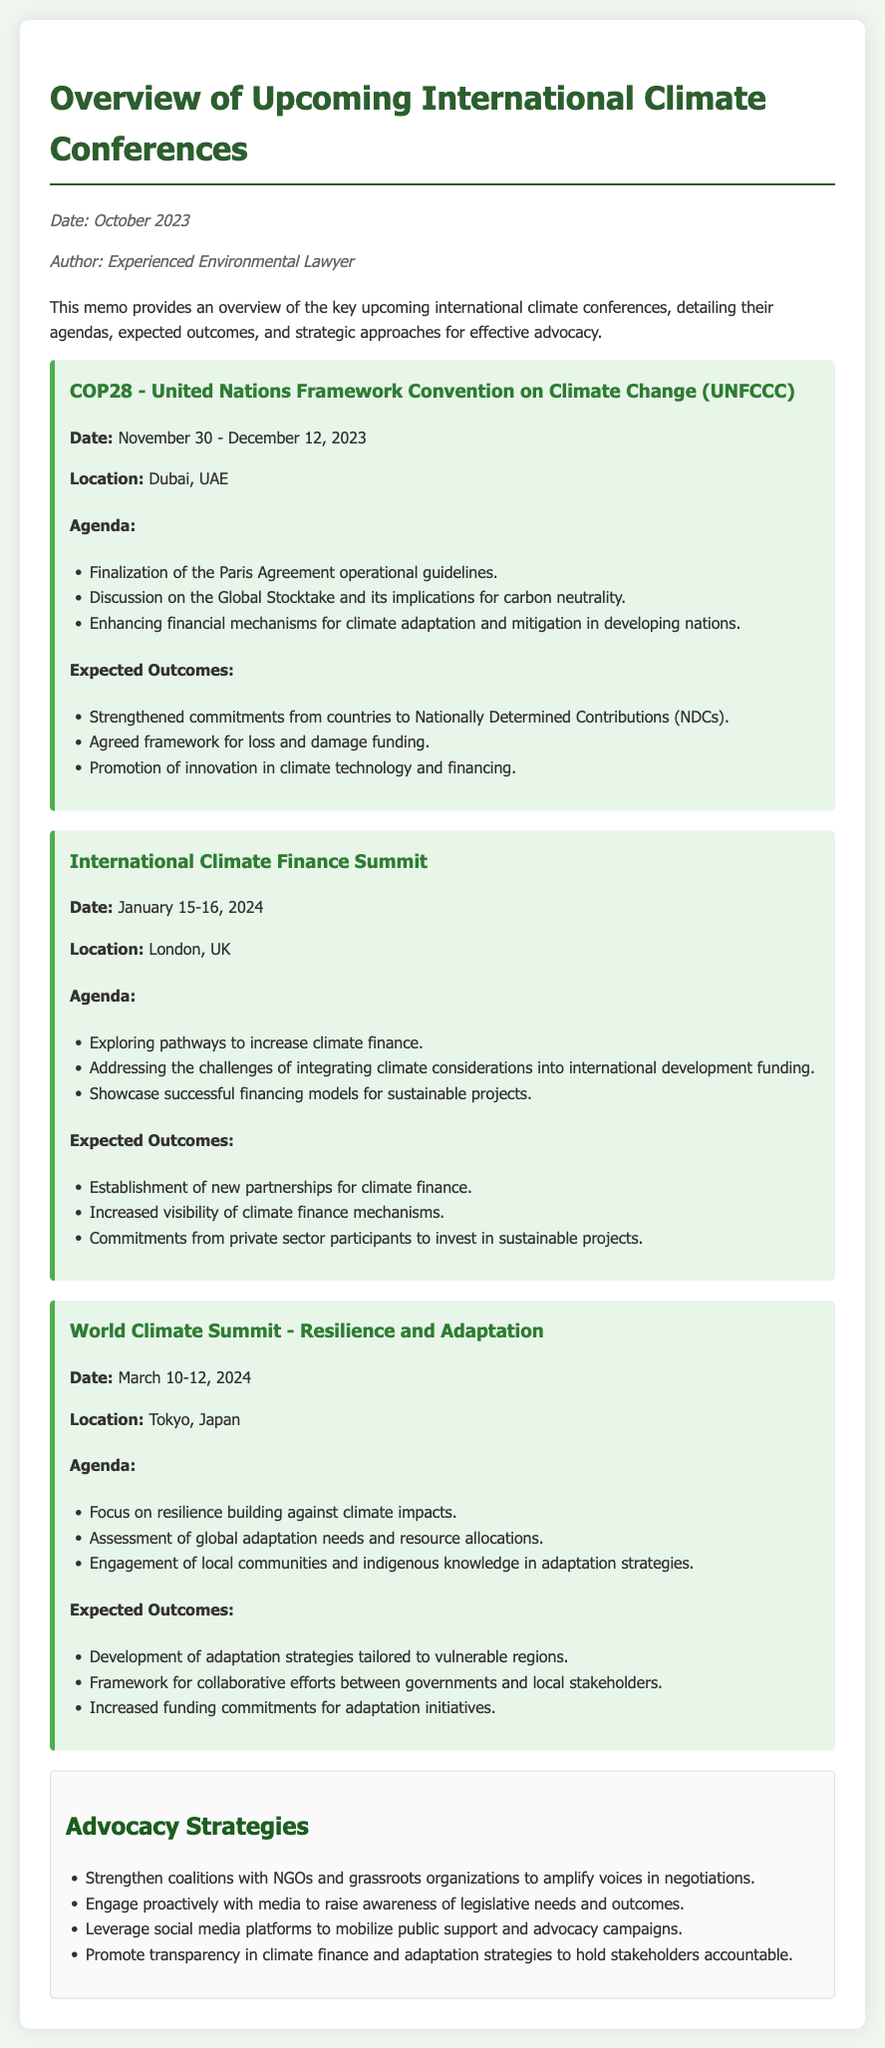What is the title of the document? The title of the document is the main heading, which specifies its purpose and topic.
Answer: Overview of Upcoming International Climate Conferences What is the date of COP28? COP28's date is explicitly stated in the memo under the conference details.
Answer: November 30 - December 12, 2023 Where will the International Climate Finance Summit take place? The location of the International Climate Finance Summit is mentioned in the document.
Answer: London, UK What is one of the expected outcomes of COP28? This expected outcome can be found in the section listing COP28's objectives and results.
Answer: Strengthened commitments from countries to Nationally Determined Contributions (NDCs) What advocacy strategy involves grassroots organizations? This strategy reflects a collective approach detailed in the memo's advocacy strategies section.
Answer: Strengthen coalitions with NGOs and grassroots organizations to amplify voices in negotiations What are the dates for the World Climate Summit? The dates for the World Climate Summit are explicitly specified in the document.
Answer: March 10-12, 2024 Which conference focuses on resilience building? The focus of the conference can be identified in the title and agenda sections listed in the memo.
Answer: World Climate Summit - Resilience and Adaptation What is one agenda item for the International Climate Finance Summit? This agenda item is taken from the list of topics planned for discussion at the summit.
Answer: Exploring pathways to increase climate finance What is the main theme of the advocacy strategies? The overall theme can be inferred from the various advocacy strategies listed in the document.
Answer: Mobilizing support for climate action 